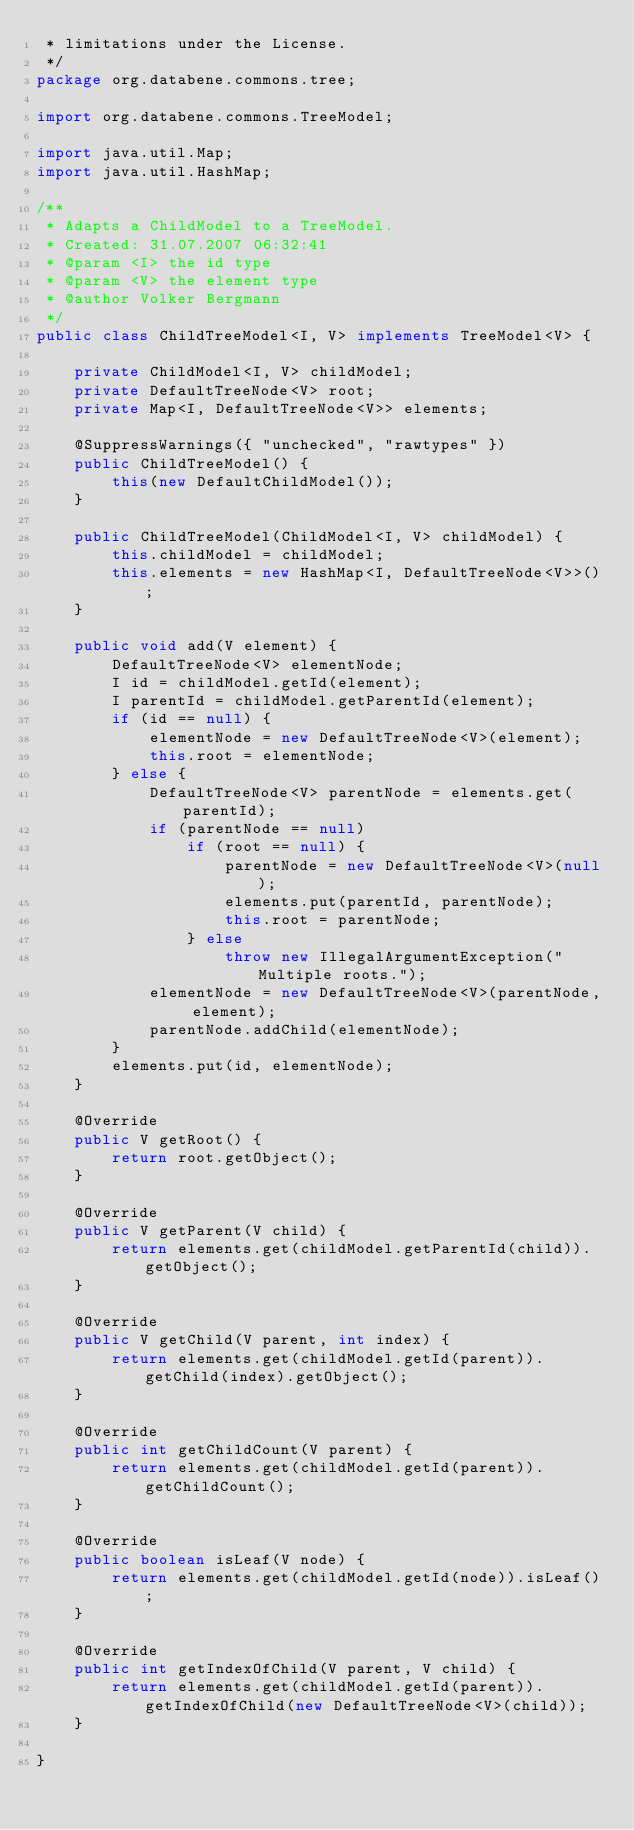<code> <loc_0><loc_0><loc_500><loc_500><_Java_> * limitations under the License.
 */
package org.databene.commons.tree;

import org.databene.commons.TreeModel;

import java.util.Map;
import java.util.HashMap;

/**
 * Adapts a ChildModel to a TreeModel.
 * Created: 31.07.2007 06:32:41
 * @param <I> the id type
 * @param <V> the element type
 * @author Volker Bergmann
 */
public class ChildTreeModel<I, V> implements TreeModel<V> {

    private ChildModel<I, V> childModel;
    private DefaultTreeNode<V> root;
    private Map<I, DefaultTreeNode<V>> elements;

    @SuppressWarnings({ "unchecked", "rawtypes" })
    public ChildTreeModel() {
        this(new DefaultChildModel());
    }

    public ChildTreeModel(ChildModel<I, V> childModel) {
        this.childModel = childModel;
        this.elements = new HashMap<I, DefaultTreeNode<V>>();
    }

    public void add(V element) {
        DefaultTreeNode<V> elementNode;
        I id = childModel.getId(element);
        I parentId = childModel.getParentId(element);
        if (id == null) {
            elementNode = new DefaultTreeNode<V>(element);
            this.root = elementNode;
        } else {
            DefaultTreeNode<V> parentNode = elements.get(parentId);
            if (parentNode == null)
                if (root == null) {
                    parentNode = new DefaultTreeNode<V>(null);
                    elements.put(parentId, parentNode);
                    this.root = parentNode;
                } else
                    throw new IllegalArgumentException("Multiple roots.");
            elementNode = new DefaultTreeNode<V>(parentNode, element);
            parentNode.addChild(elementNode);
        }
        elements.put(id, elementNode);
    }

    @Override
	public V getRoot() {
        return root.getObject();
    }

    @Override
	public V getParent(V child) {
        return elements.get(childModel.getParentId(child)).getObject();
    }

    @Override
	public V getChild(V parent, int index) {
        return elements.get(childModel.getId(parent)).getChild(index).getObject();
    }

    @Override
	public int getChildCount(V parent) {
        return elements.get(childModel.getId(parent)).getChildCount();
    }

    @Override
	public boolean isLeaf(V node) {
        return elements.get(childModel.getId(node)).isLeaf();
    }

    @Override
	public int getIndexOfChild(V parent, V child) {
        return elements.get(childModel.getId(parent)).getIndexOfChild(new DefaultTreeNode<V>(child));
    }
    
}
</code> 